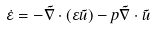Convert formula to latex. <formula><loc_0><loc_0><loc_500><loc_500>\dot { \varepsilon } = - \vec { \nabla } \cdot ( \varepsilon \vec { u } ) - p \vec { \nabla } \cdot \vec { u }</formula> 